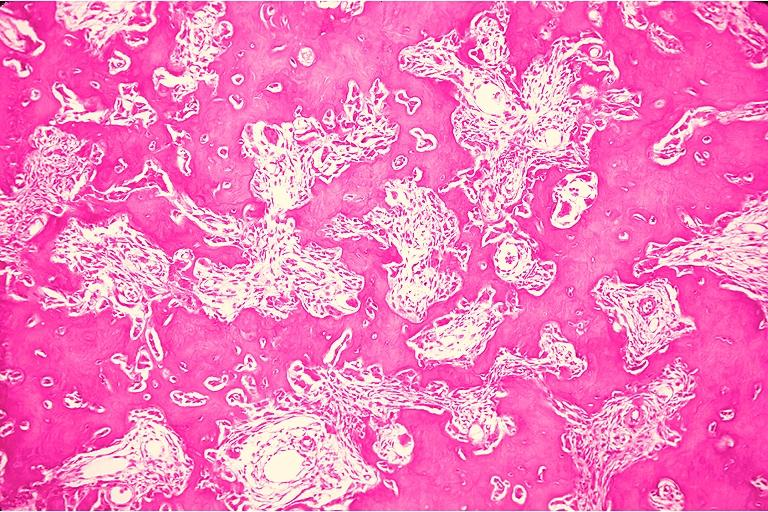where is this?
Answer the question using a single word or phrase. Oral 